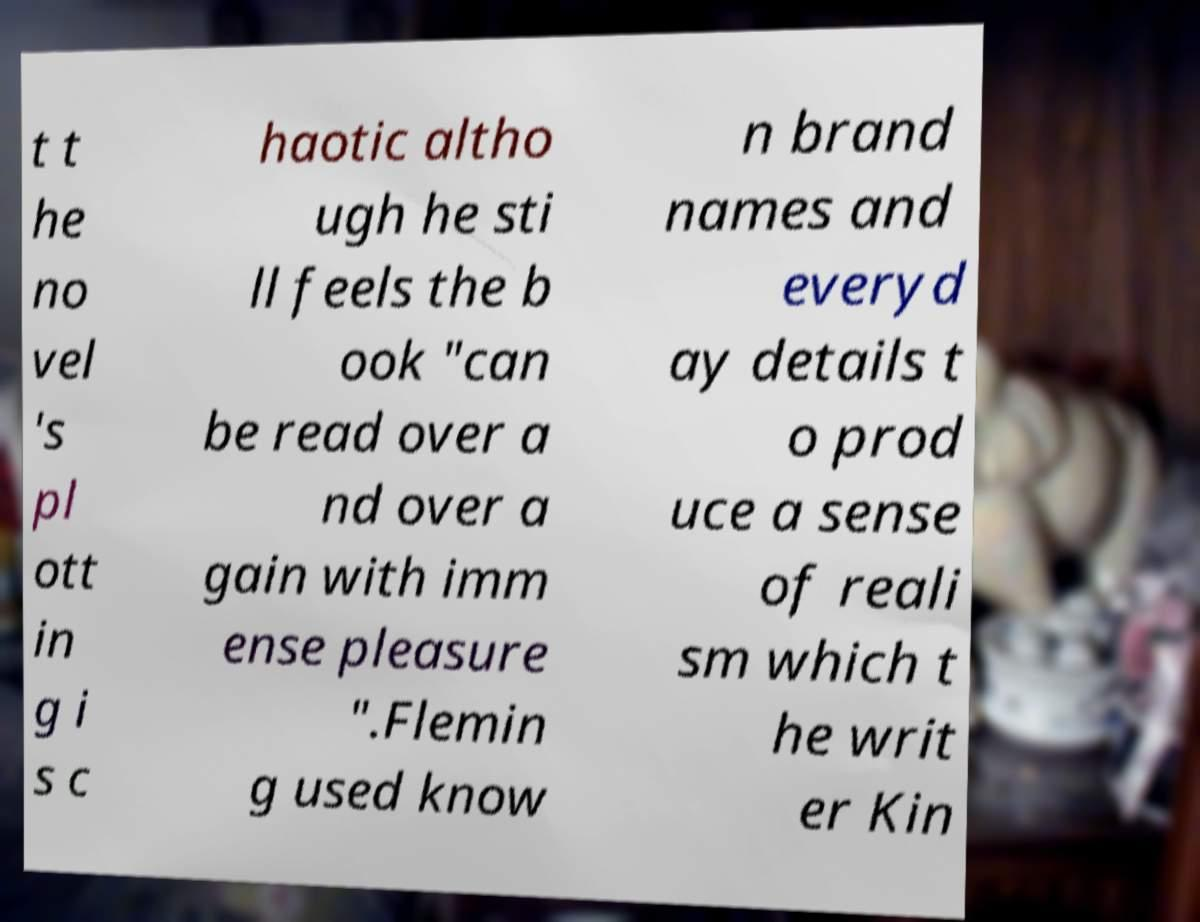What messages or text are displayed in this image? I need them in a readable, typed format. t t he no vel 's pl ott in g i s c haotic altho ugh he sti ll feels the b ook "can be read over a nd over a gain with imm ense pleasure ".Flemin g used know n brand names and everyd ay details t o prod uce a sense of reali sm which t he writ er Kin 